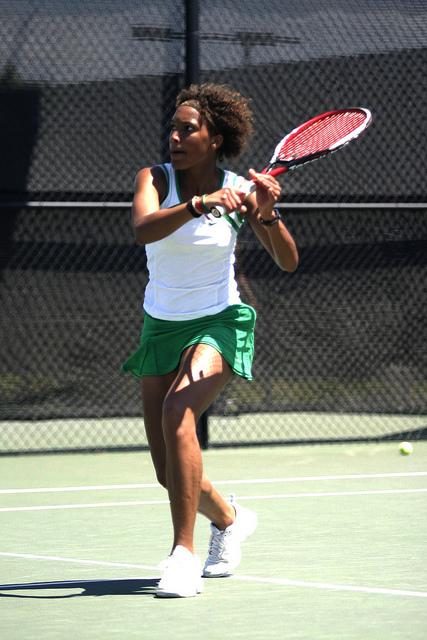What is the ethnicity of this pretty lady?
Short answer required. African american. What color is the woman's skirt?
Short answer required. Green. What color is the person's racket?
Concise answer only. Red. 